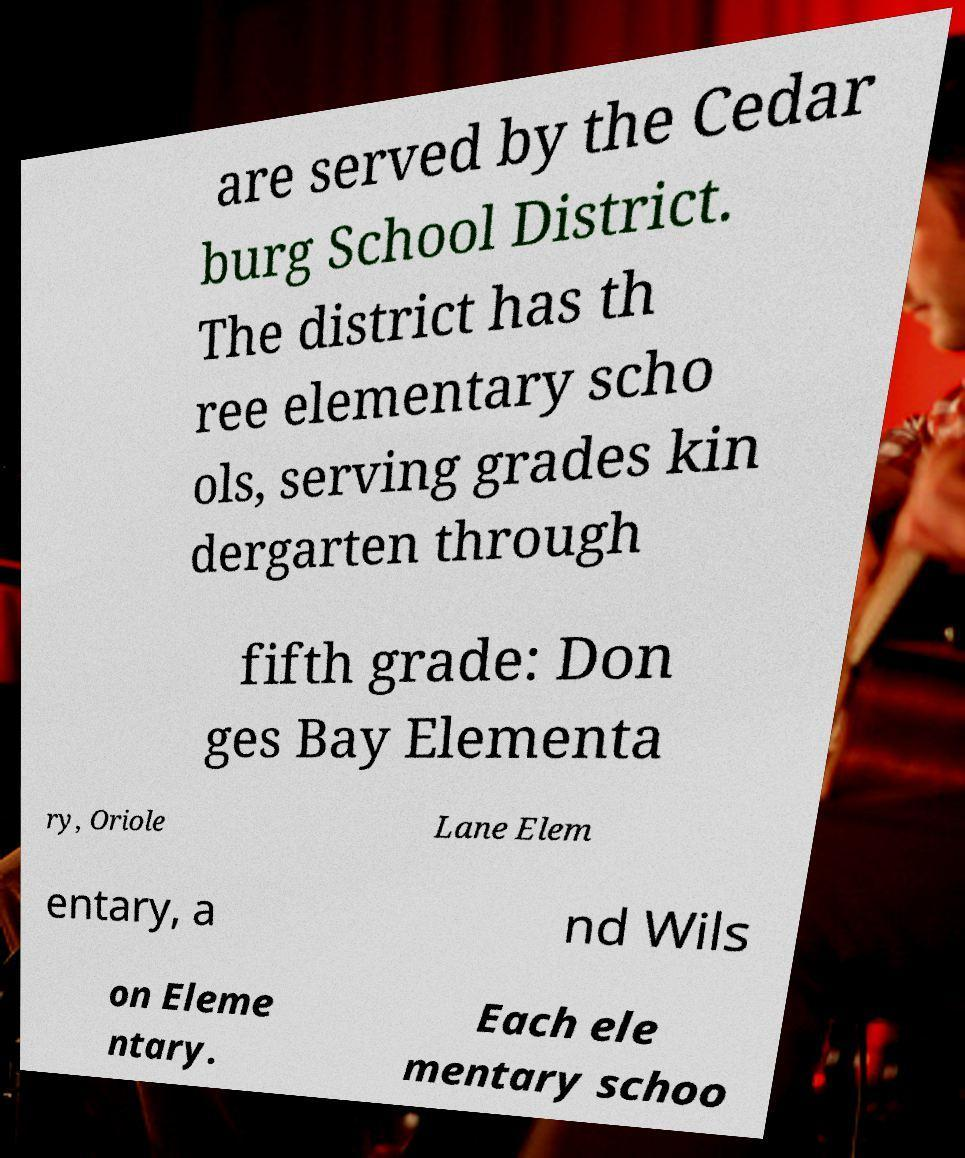Could you assist in decoding the text presented in this image and type it out clearly? are served by the Cedar burg School District. The district has th ree elementary scho ols, serving grades kin dergarten through fifth grade: Don ges Bay Elementa ry, Oriole Lane Elem entary, a nd Wils on Eleme ntary. Each ele mentary schoo 